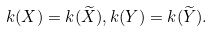<formula> <loc_0><loc_0><loc_500><loc_500>k ( X ) = k ( \widetilde { X } ) , k ( Y ) = k ( \widetilde { Y } ) .</formula> 